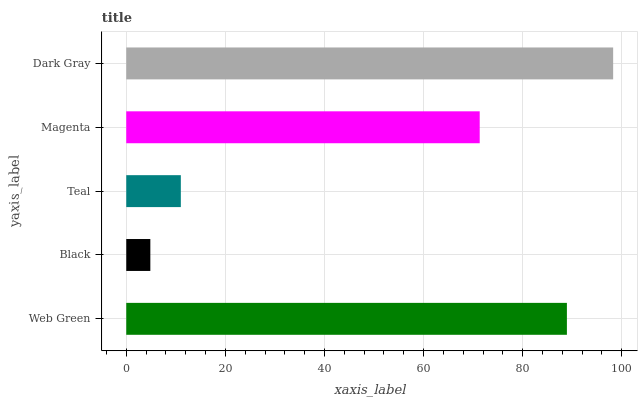Is Black the minimum?
Answer yes or no. Yes. Is Dark Gray the maximum?
Answer yes or no. Yes. Is Teal the minimum?
Answer yes or no. No. Is Teal the maximum?
Answer yes or no. No. Is Teal greater than Black?
Answer yes or no. Yes. Is Black less than Teal?
Answer yes or no. Yes. Is Black greater than Teal?
Answer yes or no. No. Is Teal less than Black?
Answer yes or no. No. Is Magenta the high median?
Answer yes or no. Yes. Is Magenta the low median?
Answer yes or no. Yes. Is Dark Gray the high median?
Answer yes or no. No. Is Black the low median?
Answer yes or no. No. 